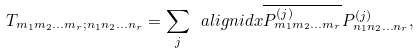<formula> <loc_0><loc_0><loc_500><loc_500>T _ { m _ { 1 } m _ { 2 } \dots m _ { r } ; n _ { 1 } n _ { 2 } \dots n _ { r } } = \sum _ { j } \ a l i g n i d x { \overline { P ^ { ( j ) } _ { m _ { 1 } m _ { 2 } \dots m _ { r } } } P ^ { ( j ) } _ { n _ { 1 } n _ { 2 } \dots n _ { r } } } ,</formula> 